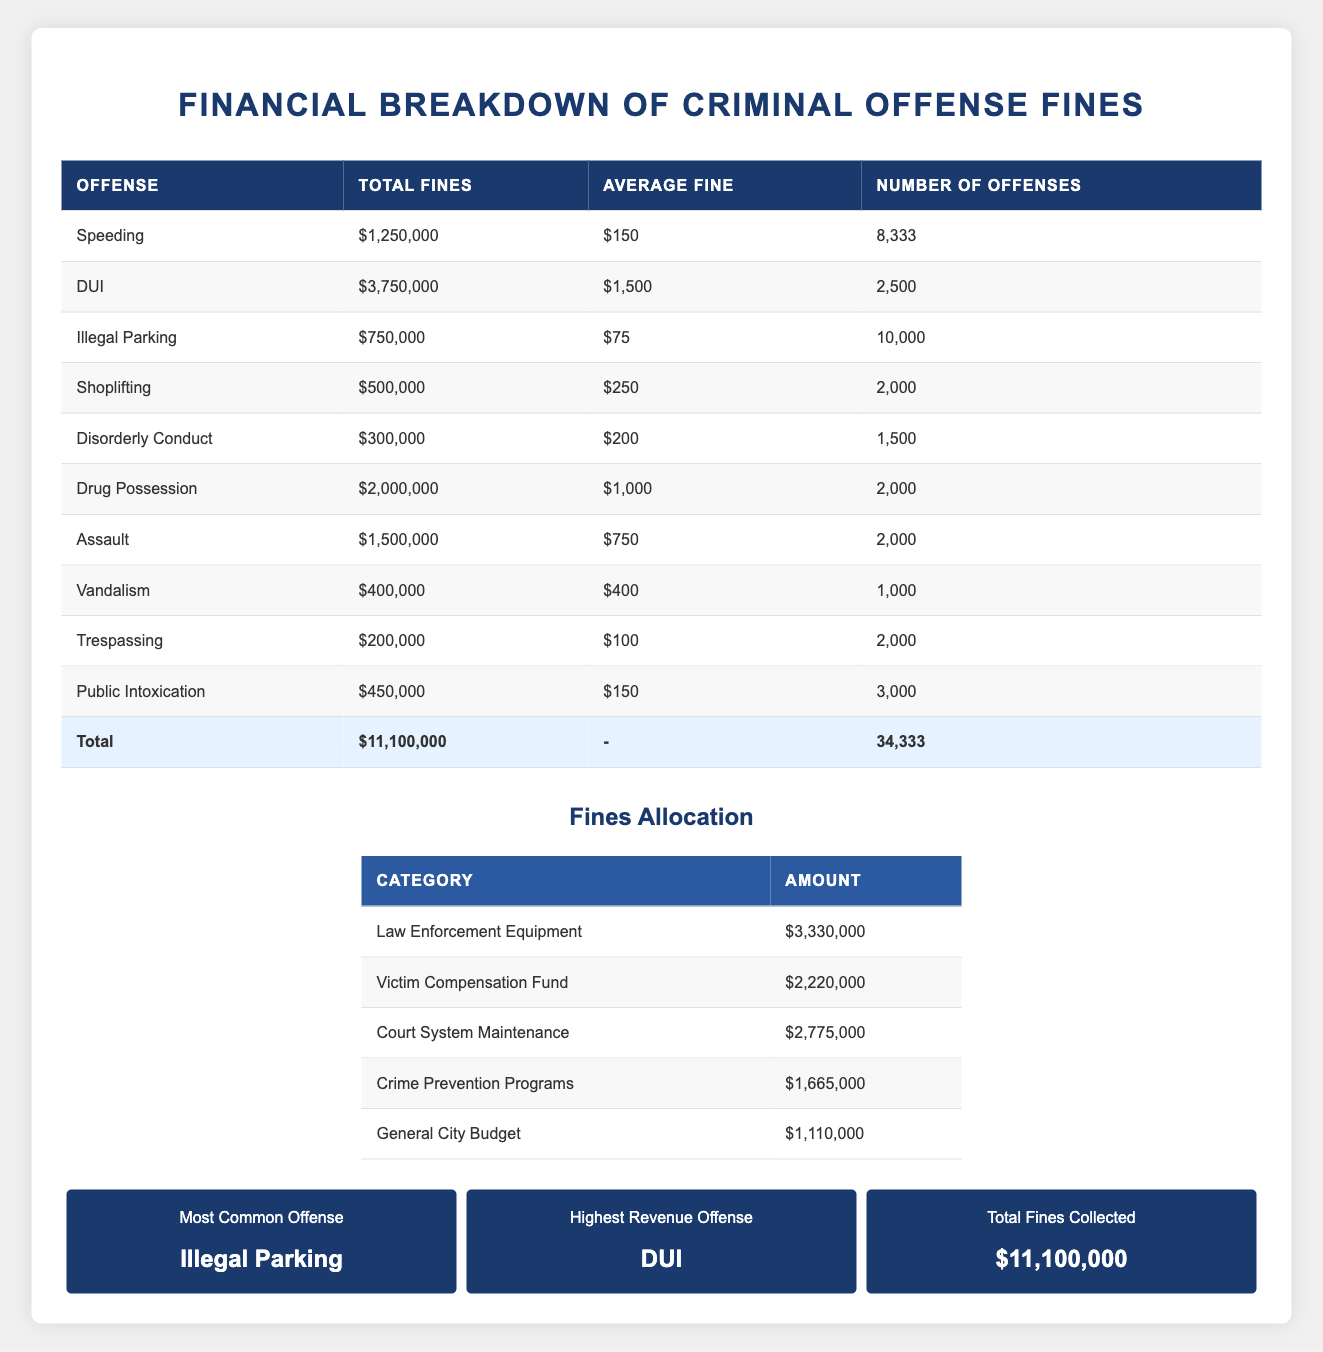What is the total amount of fines collected from all offenses? The total fines collected from all offenses can be found in the total row of the table. It states that the total fines collected is $11,100,000.
Answer: $11,100,000 Which offense generated the highest revenue? The offense that generated the highest revenue is indicated in the stats section of the table. It is listed as DUI, which has total fines of $3,750,000.
Answer: DUI How many speeding offenses contributed to the total fines collected? Looking at the speeding row, the number of offenses is provided, which is 8,333. This is the total number of speeding offenses that contributed to the fines.
Answer: 8,333 Calculate the average fine for Drug Possession. The average fine for Drug Possession is already indicated in the table under that offense, which is $1,000.
Answer: $1,000 Is the average fine for Shoplifting higher than that of Disorderly Conduct? Comparing the average fines, Shoplifting has an average fine of $250, while Disorderly Conduct has $200. Since $250 is greater than $200, the statement is true.
Answer: Yes What percentage of the total fines collected comes from Illegal Parking? The total fines from Illegal Parking are $750,000. To find the percentage, we calculate (750,000/11,100,000) * 100 = 6.76%. The result shows that approximately 6.76% of total fines come from Illegal Parking.
Answer: 6.76% How many offenses were categorized as Public Intoxication? The number of offenses for Public Intoxication is found in its respective row, where it states there were 3,000 offenses.
Answer: 3,000 What is the combined total of fines allocated to the Law Enforcement Equipment and Crime Prevention Programs? From the fines allocation section, Law Enforcement Equipment has $3,330,000 and Crime Prevention Programs have $1,665,000. Summing these two amounts gives $3,330,000 + $1,665,000 = $4,995,000.
Answer: $4,995,000 Which offense was the most common, and how many offenses were recorded? The most common offense is listed in the stats section as Illegal Parking, which had a total of 10,000 recorded offenses.
Answer: Illegal Parking, 10,000 offenses 